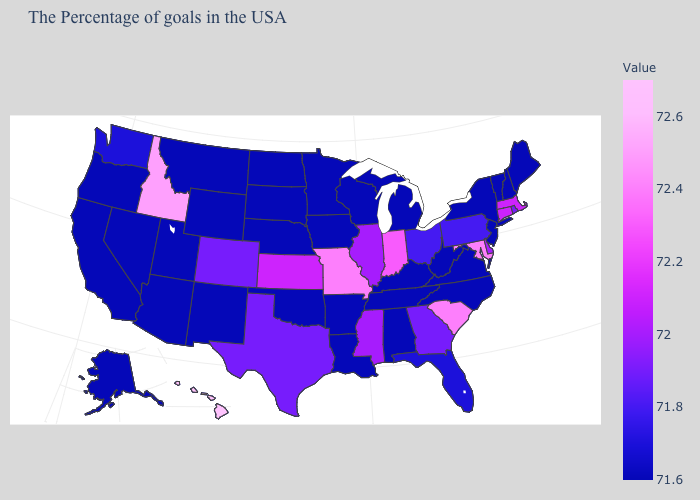Among the states that border Idaho , which have the highest value?
Short answer required. Washington. Which states have the lowest value in the MidWest?
Keep it brief. Michigan, Wisconsin, Minnesota, Iowa, Nebraska, South Dakota, North Dakota. Which states have the highest value in the USA?
Give a very brief answer. Hawaii. Which states hav the highest value in the MidWest?
Short answer required. Missouri. Which states hav the highest value in the West?
Quick response, please. Hawaii. Among the states that border Delaware , does New Jersey have the highest value?
Short answer required. No. Does New Hampshire have a higher value than Hawaii?
Short answer required. No. Does Colorado have the lowest value in the USA?
Keep it brief. No. 